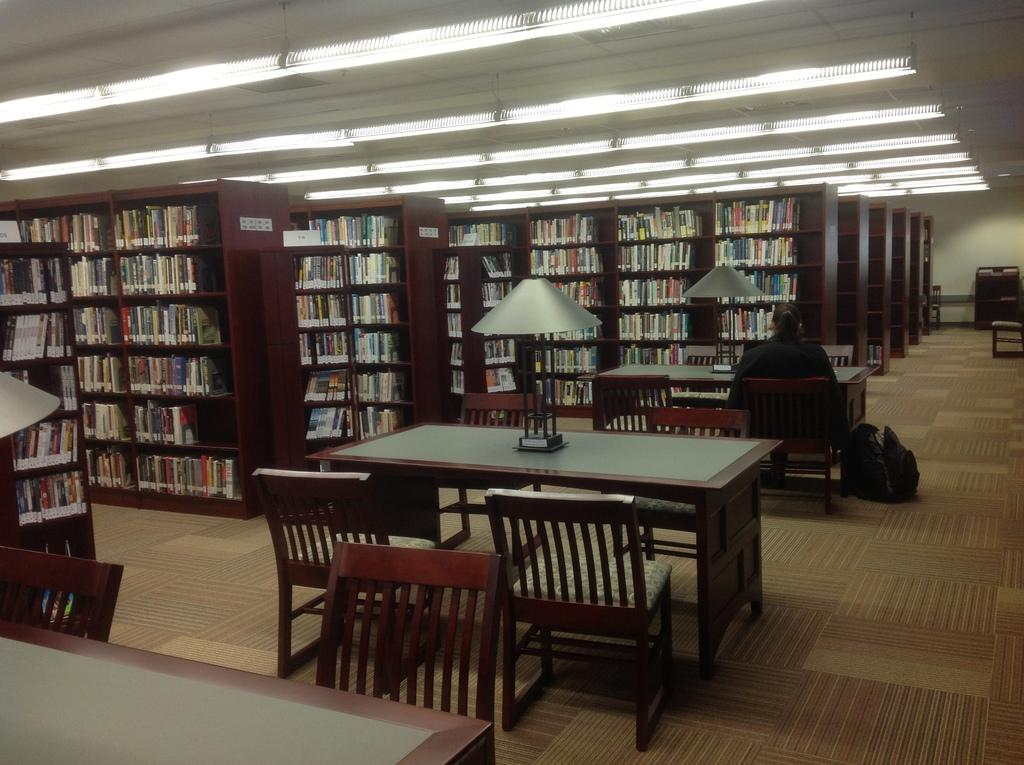What type of furniture is present in the image? There are book shelves, tables, and chairs in the image. What is the person in the image doing? The person is sitting in the right corner of the image. How many goldfish are swimming in the book shelves in the image? There are no goldfish present in the image; it features book shelves, tables, chairs, and a person sitting. What grade is the person in the image studying for? There is no indication in the image that the person is studying for a grade, as the focus is on the furniture and the person's position. 